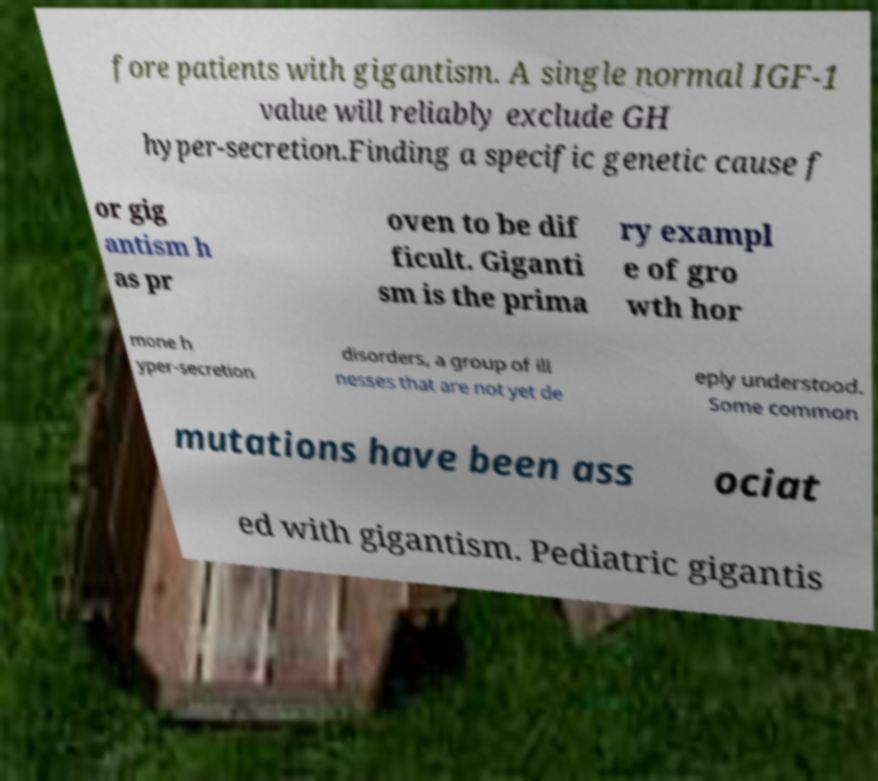I need the written content from this picture converted into text. Can you do that? fore patients with gigantism. A single normal IGF-1 value will reliably exclude GH hyper-secretion.Finding a specific genetic cause f or gig antism h as pr oven to be dif ficult. Giganti sm is the prima ry exampl e of gro wth hor mone h yper-secretion disorders, a group of ill nesses that are not yet de eply understood. Some common mutations have been ass ociat ed with gigantism. Pediatric gigantis 